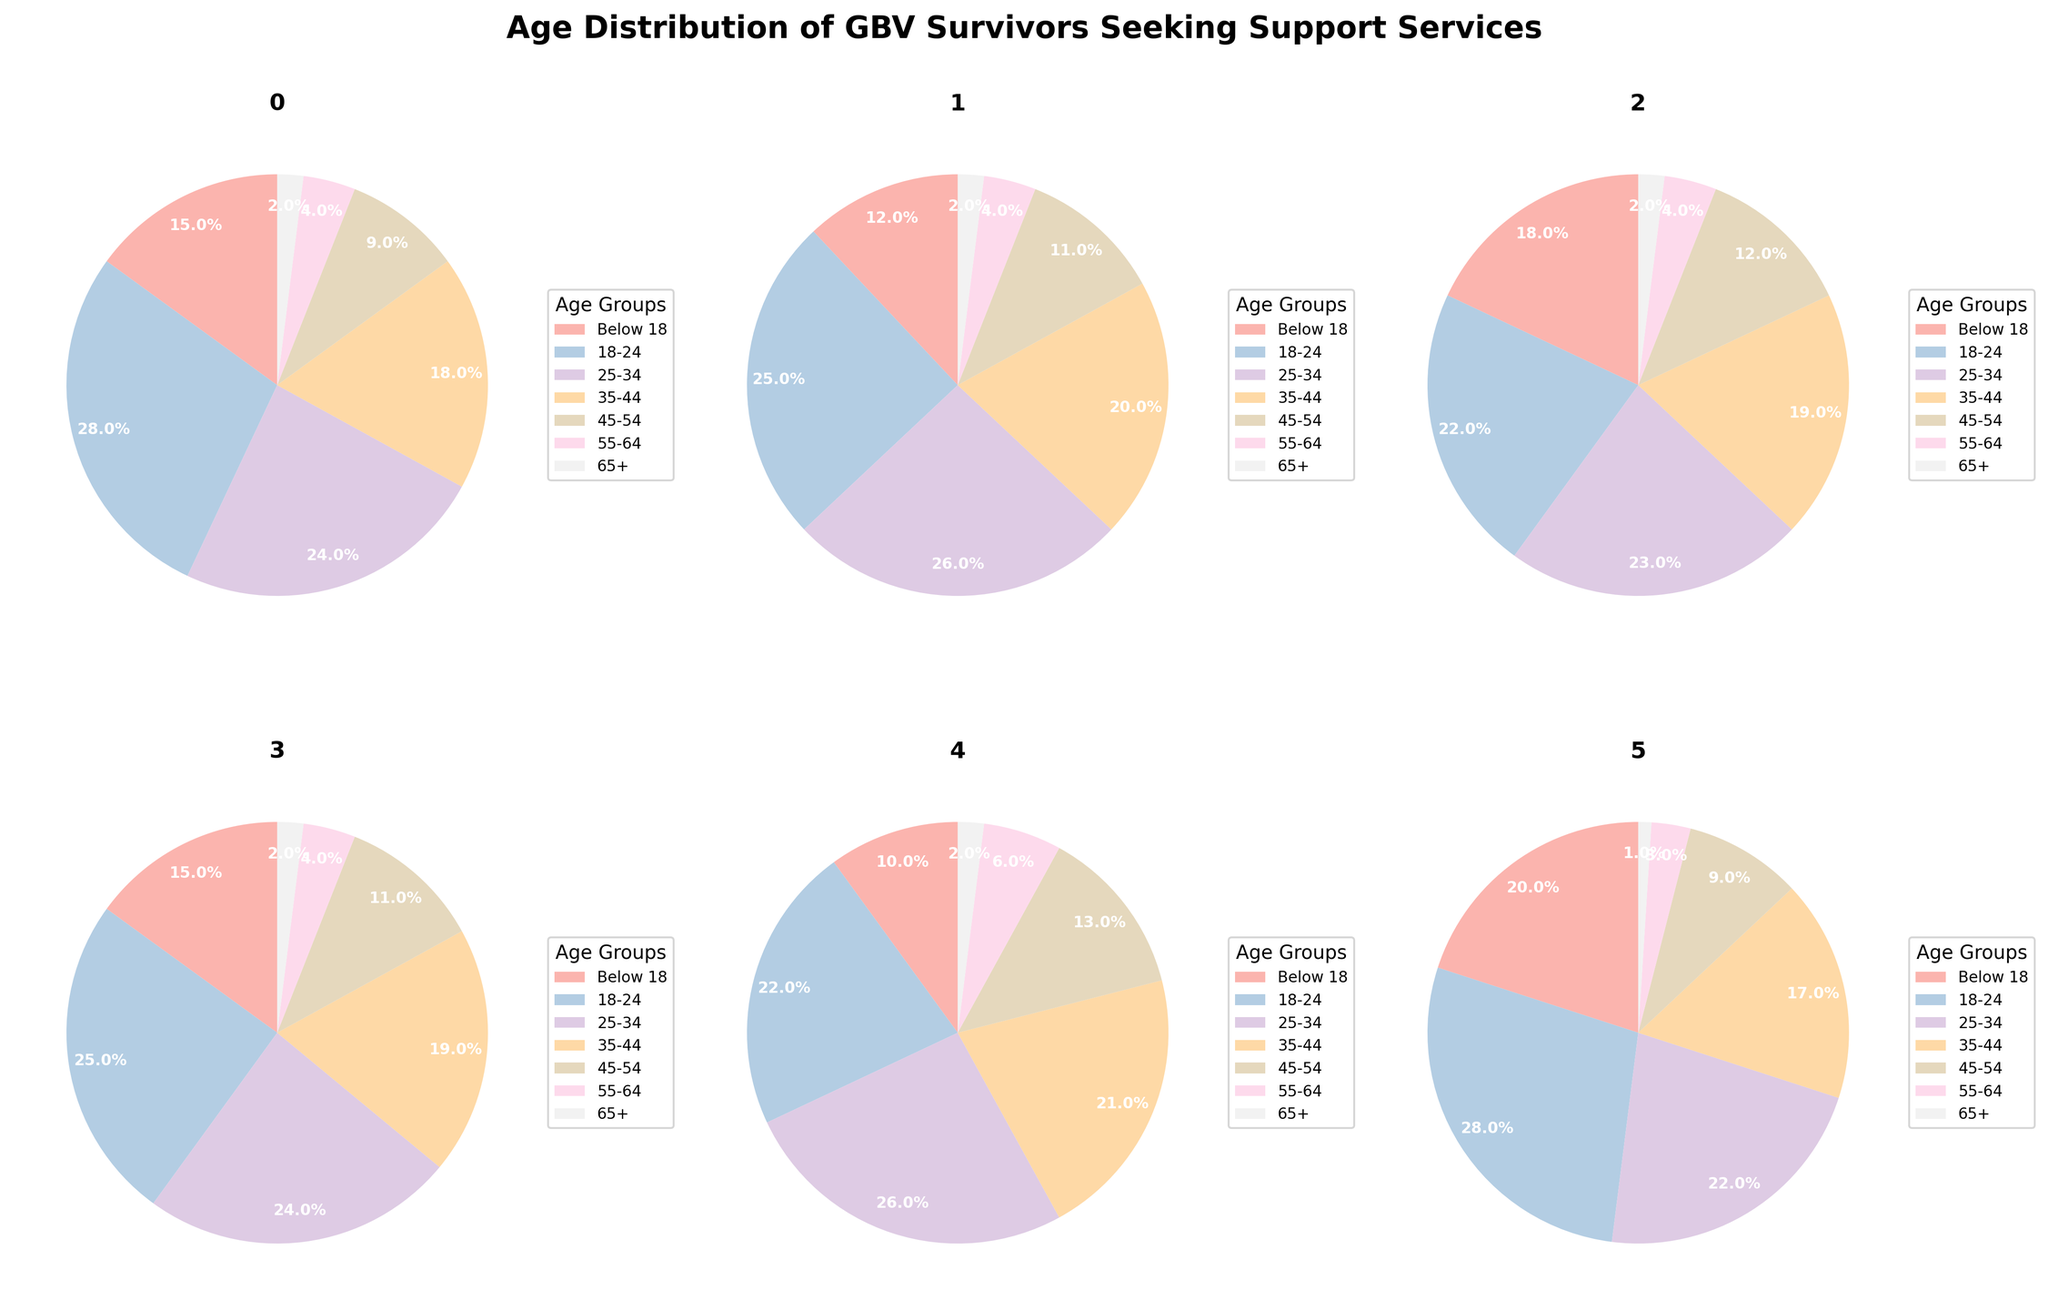What's the percentage of survivors below 18 in suburban areas? In the suburban areas pie chart, identify the slice labeled "Below 18," which represents 12%.
Answer: 12% Which area has the highest percentage of survivors aged 25-34? Compare the percentages for the 25-34 age group in all six pie charts. The suburban areas have the highest percentage at 26%.
Answer: Suburban Areas What is the sum of percentages of survivors aged 45-54 and 55-64 in rural areas? In the rural areas pie chart, the slices for ages 45-54 and 55-64 represent 12% and 4%, respectively. Sum these values: 12% + 4% = 16%.
Answer: 16% Which age group has the lowest percentage in high-income countries? In the high-income countries pie chart, find the slice with the smallest percentage. The 65+ age group is the smallest, with 2%.
Answer: 65+ How does the percentage of survivors below 18 in low-income countries compare to the national average? In the low-income countries pie chart, the slice for ages below 18 is 20%. The national average for the same age group is 15%, so the percentage is higher in low-income countries.
Answer: Higher What is the difference in the percentage of survivors aged 18-24 between urban areas and low-income countries? In the urban areas pie chart, the slice for ages 18-24 is 28%. In low-income countries, it is also 28%. The difference is 0.
Answer: 0 What's the combined percentage of survivors aged 35-44 across all three types of areas (urban, suburban, and rural)? In the urban, suburban, and rural areas pie charts, the slices for ages 35-44 are 18%, 20%, and 19%, respectively. Sum these values: 18% + 20% + 19% = 57%.
Answer: 57% Which area shows the most even distribution among age groups? Examine the pie charts to see which has slices that are most similar in size. The national average pie chart appears to show the most even distribution.
Answer: National Average What is the average percentage of survivors aged 45-54 in high-income and low-income countries? In the high-income countries pie chart, the slice for ages 45-54 is 13%. In low-income countries, it is 9%. The average is: (13% + 9%) / 2 = 11%.
Answer: 11% What's the percentage difference between survivors aged 25-34 in urban areas and rural areas? In the urban areas pie chart, the slice for ages 25-34 is 24%. In rural areas, it's 23%. The difference is 24% - 23% = 1%.
Answer: 1% 